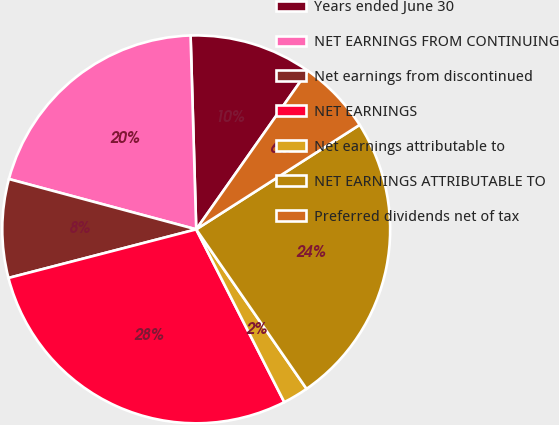Convert chart to OTSL. <chart><loc_0><loc_0><loc_500><loc_500><pie_chart><fcel>Years ended June 30<fcel>NET EARNINGS FROM CONTINUING<fcel>Net earnings from discontinued<fcel>NET EARNINGS<fcel>Net earnings attributable to<fcel>NET EARNINGS ATTRIBUTABLE TO<fcel>Preferred dividends net of tax<nl><fcel>10.23%<fcel>20.36%<fcel>8.21%<fcel>28.47%<fcel>2.13%<fcel>24.42%<fcel>6.18%<nl></chart> 